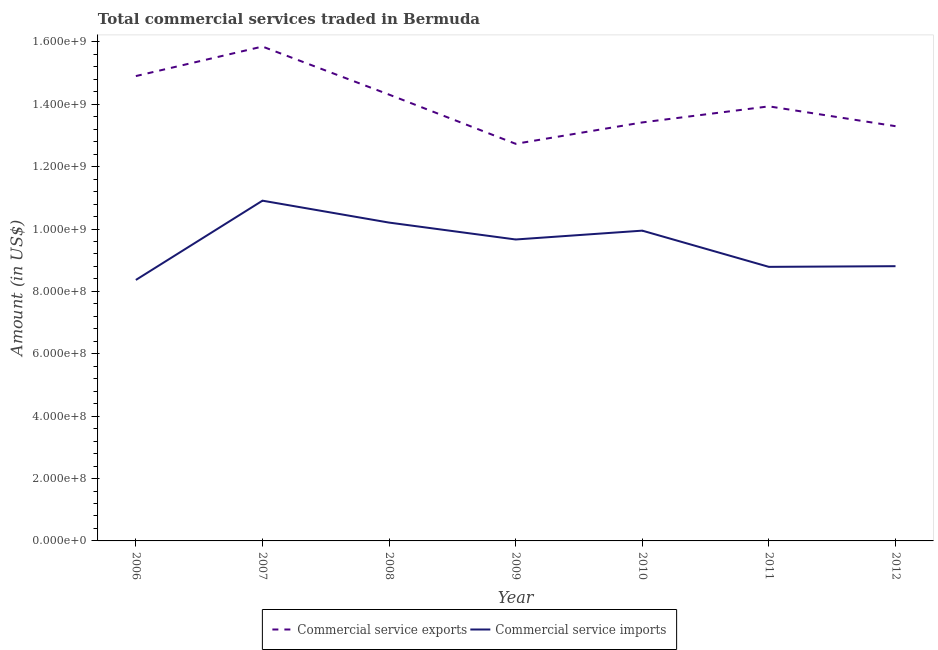How many different coloured lines are there?
Your answer should be compact. 2. Is the number of lines equal to the number of legend labels?
Provide a short and direct response. Yes. What is the amount of commercial service imports in 2007?
Give a very brief answer. 1.09e+09. Across all years, what is the maximum amount of commercial service imports?
Make the answer very short. 1.09e+09. Across all years, what is the minimum amount of commercial service imports?
Ensure brevity in your answer.  8.37e+08. What is the total amount of commercial service exports in the graph?
Offer a terse response. 9.84e+09. What is the difference between the amount of commercial service imports in 2007 and that in 2008?
Your response must be concise. 7.03e+07. What is the difference between the amount of commercial service exports in 2010 and the amount of commercial service imports in 2006?
Offer a terse response. 5.05e+08. What is the average amount of commercial service imports per year?
Provide a short and direct response. 9.53e+08. In the year 2006, what is the difference between the amount of commercial service imports and amount of commercial service exports?
Your answer should be very brief. -6.54e+08. In how many years, is the amount of commercial service exports greater than 1200000000 US$?
Keep it short and to the point. 7. What is the ratio of the amount of commercial service exports in 2006 to that in 2010?
Make the answer very short. 1.11. Is the amount of commercial service imports in 2010 less than that in 2011?
Provide a short and direct response. No. What is the difference between the highest and the second highest amount of commercial service imports?
Provide a short and direct response. 7.03e+07. What is the difference between the highest and the lowest amount of commercial service exports?
Your response must be concise. 3.12e+08. In how many years, is the amount of commercial service imports greater than the average amount of commercial service imports taken over all years?
Offer a terse response. 4. Is the sum of the amount of commercial service exports in 2010 and 2011 greater than the maximum amount of commercial service imports across all years?
Your response must be concise. Yes. Does the amount of commercial service imports monotonically increase over the years?
Your response must be concise. No. How many lines are there?
Give a very brief answer. 2. How many years are there in the graph?
Provide a short and direct response. 7. Does the graph contain any zero values?
Offer a terse response. No. How many legend labels are there?
Your answer should be compact. 2. How are the legend labels stacked?
Provide a short and direct response. Horizontal. What is the title of the graph?
Give a very brief answer. Total commercial services traded in Bermuda. What is the Amount (in US$) of Commercial service exports in 2006?
Your answer should be very brief. 1.49e+09. What is the Amount (in US$) in Commercial service imports in 2006?
Your answer should be compact. 8.37e+08. What is the Amount (in US$) of Commercial service exports in 2007?
Offer a very short reply. 1.58e+09. What is the Amount (in US$) of Commercial service imports in 2007?
Your answer should be compact. 1.09e+09. What is the Amount (in US$) in Commercial service exports in 2008?
Provide a succinct answer. 1.43e+09. What is the Amount (in US$) of Commercial service imports in 2008?
Offer a terse response. 1.02e+09. What is the Amount (in US$) of Commercial service exports in 2009?
Ensure brevity in your answer.  1.27e+09. What is the Amount (in US$) of Commercial service imports in 2009?
Offer a terse response. 9.66e+08. What is the Amount (in US$) in Commercial service exports in 2010?
Your response must be concise. 1.34e+09. What is the Amount (in US$) in Commercial service imports in 2010?
Make the answer very short. 9.95e+08. What is the Amount (in US$) in Commercial service exports in 2011?
Provide a short and direct response. 1.39e+09. What is the Amount (in US$) of Commercial service imports in 2011?
Provide a short and direct response. 8.79e+08. What is the Amount (in US$) in Commercial service exports in 2012?
Keep it short and to the point. 1.33e+09. What is the Amount (in US$) of Commercial service imports in 2012?
Ensure brevity in your answer.  8.81e+08. Across all years, what is the maximum Amount (in US$) in Commercial service exports?
Make the answer very short. 1.58e+09. Across all years, what is the maximum Amount (in US$) of Commercial service imports?
Provide a short and direct response. 1.09e+09. Across all years, what is the minimum Amount (in US$) of Commercial service exports?
Keep it short and to the point. 1.27e+09. Across all years, what is the minimum Amount (in US$) in Commercial service imports?
Make the answer very short. 8.37e+08. What is the total Amount (in US$) of Commercial service exports in the graph?
Ensure brevity in your answer.  9.84e+09. What is the total Amount (in US$) in Commercial service imports in the graph?
Provide a succinct answer. 6.67e+09. What is the difference between the Amount (in US$) in Commercial service exports in 2006 and that in 2007?
Provide a succinct answer. -9.47e+07. What is the difference between the Amount (in US$) in Commercial service imports in 2006 and that in 2007?
Your answer should be compact. -2.54e+08. What is the difference between the Amount (in US$) in Commercial service exports in 2006 and that in 2008?
Keep it short and to the point. 5.94e+07. What is the difference between the Amount (in US$) in Commercial service imports in 2006 and that in 2008?
Your answer should be very brief. -1.84e+08. What is the difference between the Amount (in US$) of Commercial service exports in 2006 and that in 2009?
Provide a short and direct response. 2.17e+08. What is the difference between the Amount (in US$) in Commercial service imports in 2006 and that in 2009?
Your answer should be compact. -1.30e+08. What is the difference between the Amount (in US$) of Commercial service exports in 2006 and that in 2010?
Keep it short and to the point. 1.49e+08. What is the difference between the Amount (in US$) in Commercial service imports in 2006 and that in 2010?
Keep it short and to the point. -1.58e+08. What is the difference between the Amount (in US$) of Commercial service exports in 2006 and that in 2011?
Offer a terse response. 9.71e+07. What is the difference between the Amount (in US$) of Commercial service imports in 2006 and that in 2011?
Your answer should be compact. -4.20e+07. What is the difference between the Amount (in US$) of Commercial service exports in 2006 and that in 2012?
Offer a terse response. 1.61e+08. What is the difference between the Amount (in US$) of Commercial service imports in 2006 and that in 2012?
Ensure brevity in your answer.  -4.41e+07. What is the difference between the Amount (in US$) in Commercial service exports in 2007 and that in 2008?
Your response must be concise. 1.54e+08. What is the difference between the Amount (in US$) in Commercial service imports in 2007 and that in 2008?
Give a very brief answer. 7.03e+07. What is the difference between the Amount (in US$) in Commercial service exports in 2007 and that in 2009?
Your response must be concise. 3.12e+08. What is the difference between the Amount (in US$) of Commercial service imports in 2007 and that in 2009?
Keep it short and to the point. 1.24e+08. What is the difference between the Amount (in US$) of Commercial service exports in 2007 and that in 2010?
Your answer should be very brief. 2.43e+08. What is the difference between the Amount (in US$) of Commercial service imports in 2007 and that in 2010?
Offer a very short reply. 9.61e+07. What is the difference between the Amount (in US$) in Commercial service exports in 2007 and that in 2011?
Your response must be concise. 1.92e+08. What is the difference between the Amount (in US$) in Commercial service imports in 2007 and that in 2011?
Give a very brief answer. 2.12e+08. What is the difference between the Amount (in US$) of Commercial service exports in 2007 and that in 2012?
Make the answer very short. 2.55e+08. What is the difference between the Amount (in US$) of Commercial service imports in 2007 and that in 2012?
Provide a succinct answer. 2.10e+08. What is the difference between the Amount (in US$) of Commercial service exports in 2008 and that in 2009?
Make the answer very short. 1.58e+08. What is the difference between the Amount (in US$) in Commercial service imports in 2008 and that in 2009?
Your answer should be compact. 5.42e+07. What is the difference between the Amount (in US$) in Commercial service exports in 2008 and that in 2010?
Give a very brief answer. 8.92e+07. What is the difference between the Amount (in US$) in Commercial service imports in 2008 and that in 2010?
Provide a succinct answer. 2.58e+07. What is the difference between the Amount (in US$) of Commercial service exports in 2008 and that in 2011?
Make the answer very short. 3.77e+07. What is the difference between the Amount (in US$) in Commercial service imports in 2008 and that in 2011?
Your response must be concise. 1.42e+08. What is the difference between the Amount (in US$) in Commercial service exports in 2008 and that in 2012?
Your response must be concise. 1.01e+08. What is the difference between the Amount (in US$) in Commercial service imports in 2008 and that in 2012?
Keep it short and to the point. 1.40e+08. What is the difference between the Amount (in US$) of Commercial service exports in 2009 and that in 2010?
Offer a very short reply. -6.86e+07. What is the difference between the Amount (in US$) of Commercial service imports in 2009 and that in 2010?
Provide a succinct answer. -2.83e+07. What is the difference between the Amount (in US$) of Commercial service exports in 2009 and that in 2011?
Provide a succinct answer. -1.20e+08. What is the difference between the Amount (in US$) of Commercial service imports in 2009 and that in 2011?
Provide a short and direct response. 8.78e+07. What is the difference between the Amount (in US$) in Commercial service exports in 2009 and that in 2012?
Provide a succinct answer. -5.66e+07. What is the difference between the Amount (in US$) of Commercial service imports in 2009 and that in 2012?
Make the answer very short. 8.56e+07. What is the difference between the Amount (in US$) in Commercial service exports in 2010 and that in 2011?
Offer a terse response. -5.15e+07. What is the difference between the Amount (in US$) in Commercial service imports in 2010 and that in 2011?
Offer a very short reply. 1.16e+08. What is the difference between the Amount (in US$) of Commercial service exports in 2010 and that in 2012?
Give a very brief answer. 1.20e+07. What is the difference between the Amount (in US$) of Commercial service imports in 2010 and that in 2012?
Offer a very short reply. 1.14e+08. What is the difference between the Amount (in US$) in Commercial service exports in 2011 and that in 2012?
Your response must be concise. 6.35e+07. What is the difference between the Amount (in US$) in Commercial service imports in 2011 and that in 2012?
Give a very brief answer. -2.16e+06. What is the difference between the Amount (in US$) of Commercial service exports in 2006 and the Amount (in US$) of Commercial service imports in 2007?
Make the answer very short. 3.99e+08. What is the difference between the Amount (in US$) of Commercial service exports in 2006 and the Amount (in US$) of Commercial service imports in 2008?
Offer a terse response. 4.70e+08. What is the difference between the Amount (in US$) of Commercial service exports in 2006 and the Amount (in US$) of Commercial service imports in 2009?
Provide a short and direct response. 5.24e+08. What is the difference between the Amount (in US$) of Commercial service exports in 2006 and the Amount (in US$) of Commercial service imports in 2010?
Provide a short and direct response. 4.96e+08. What is the difference between the Amount (in US$) in Commercial service exports in 2006 and the Amount (in US$) in Commercial service imports in 2011?
Offer a very short reply. 6.12e+08. What is the difference between the Amount (in US$) in Commercial service exports in 2006 and the Amount (in US$) in Commercial service imports in 2012?
Keep it short and to the point. 6.10e+08. What is the difference between the Amount (in US$) in Commercial service exports in 2007 and the Amount (in US$) in Commercial service imports in 2008?
Ensure brevity in your answer.  5.64e+08. What is the difference between the Amount (in US$) of Commercial service exports in 2007 and the Amount (in US$) of Commercial service imports in 2009?
Provide a short and direct response. 6.19e+08. What is the difference between the Amount (in US$) of Commercial service exports in 2007 and the Amount (in US$) of Commercial service imports in 2010?
Give a very brief answer. 5.90e+08. What is the difference between the Amount (in US$) of Commercial service exports in 2007 and the Amount (in US$) of Commercial service imports in 2011?
Your response must be concise. 7.06e+08. What is the difference between the Amount (in US$) of Commercial service exports in 2007 and the Amount (in US$) of Commercial service imports in 2012?
Offer a very short reply. 7.04e+08. What is the difference between the Amount (in US$) in Commercial service exports in 2008 and the Amount (in US$) in Commercial service imports in 2009?
Make the answer very short. 4.65e+08. What is the difference between the Amount (in US$) of Commercial service exports in 2008 and the Amount (in US$) of Commercial service imports in 2010?
Offer a very short reply. 4.36e+08. What is the difference between the Amount (in US$) in Commercial service exports in 2008 and the Amount (in US$) in Commercial service imports in 2011?
Provide a short and direct response. 5.52e+08. What is the difference between the Amount (in US$) of Commercial service exports in 2008 and the Amount (in US$) of Commercial service imports in 2012?
Offer a terse response. 5.50e+08. What is the difference between the Amount (in US$) of Commercial service exports in 2009 and the Amount (in US$) of Commercial service imports in 2010?
Your answer should be very brief. 2.78e+08. What is the difference between the Amount (in US$) of Commercial service exports in 2009 and the Amount (in US$) of Commercial service imports in 2011?
Your answer should be very brief. 3.94e+08. What is the difference between the Amount (in US$) in Commercial service exports in 2009 and the Amount (in US$) in Commercial service imports in 2012?
Your answer should be compact. 3.92e+08. What is the difference between the Amount (in US$) in Commercial service exports in 2010 and the Amount (in US$) in Commercial service imports in 2011?
Offer a terse response. 4.63e+08. What is the difference between the Amount (in US$) of Commercial service exports in 2010 and the Amount (in US$) of Commercial service imports in 2012?
Give a very brief answer. 4.61e+08. What is the difference between the Amount (in US$) in Commercial service exports in 2011 and the Amount (in US$) in Commercial service imports in 2012?
Offer a terse response. 5.12e+08. What is the average Amount (in US$) of Commercial service exports per year?
Offer a very short reply. 1.41e+09. What is the average Amount (in US$) of Commercial service imports per year?
Provide a short and direct response. 9.53e+08. In the year 2006, what is the difference between the Amount (in US$) of Commercial service exports and Amount (in US$) of Commercial service imports?
Make the answer very short. 6.54e+08. In the year 2007, what is the difference between the Amount (in US$) in Commercial service exports and Amount (in US$) in Commercial service imports?
Keep it short and to the point. 4.94e+08. In the year 2008, what is the difference between the Amount (in US$) of Commercial service exports and Amount (in US$) of Commercial service imports?
Your answer should be compact. 4.10e+08. In the year 2009, what is the difference between the Amount (in US$) of Commercial service exports and Amount (in US$) of Commercial service imports?
Make the answer very short. 3.07e+08. In the year 2010, what is the difference between the Amount (in US$) in Commercial service exports and Amount (in US$) in Commercial service imports?
Offer a terse response. 3.47e+08. In the year 2011, what is the difference between the Amount (in US$) of Commercial service exports and Amount (in US$) of Commercial service imports?
Give a very brief answer. 5.15e+08. In the year 2012, what is the difference between the Amount (in US$) in Commercial service exports and Amount (in US$) in Commercial service imports?
Offer a terse response. 4.49e+08. What is the ratio of the Amount (in US$) in Commercial service exports in 2006 to that in 2007?
Offer a terse response. 0.94. What is the ratio of the Amount (in US$) of Commercial service imports in 2006 to that in 2007?
Offer a very short reply. 0.77. What is the ratio of the Amount (in US$) of Commercial service exports in 2006 to that in 2008?
Offer a very short reply. 1.04. What is the ratio of the Amount (in US$) in Commercial service imports in 2006 to that in 2008?
Make the answer very short. 0.82. What is the ratio of the Amount (in US$) in Commercial service exports in 2006 to that in 2009?
Ensure brevity in your answer.  1.17. What is the ratio of the Amount (in US$) of Commercial service imports in 2006 to that in 2009?
Offer a terse response. 0.87. What is the ratio of the Amount (in US$) in Commercial service exports in 2006 to that in 2010?
Make the answer very short. 1.11. What is the ratio of the Amount (in US$) in Commercial service imports in 2006 to that in 2010?
Make the answer very short. 0.84. What is the ratio of the Amount (in US$) of Commercial service exports in 2006 to that in 2011?
Keep it short and to the point. 1.07. What is the ratio of the Amount (in US$) of Commercial service imports in 2006 to that in 2011?
Your response must be concise. 0.95. What is the ratio of the Amount (in US$) in Commercial service exports in 2006 to that in 2012?
Offer a very short reply. 1.12. What is the ratio of the Amount (in US$) of Commercial service imports in 2006 to that in 2012?
Your answer should be very brief. 0.95. What is the ratio of the Amount (in US$) of Commercial service exports in 2007 to that in 2008?
Your response must be concise. 1.11. What is the ratio of the Amount (in US$) in Commercial service imports in 2007 to that in 2008?
Ensure brevity in your answer.  1.07. What is the ratio of the Amount (in US$) of Commercial service exports in 2007 to that in 2009?
Provide a short and direct response. 1.25. What is the ratio of the Amount (in US$) of Commercial service imports in 2007 to that in 2009?
Offer a terse response. 1.13. What is the ratio of the Amount (in US$) in Commercial service exports in 2007 to that in 2010?
Provide a short and direct response. 1.18. What is the ratio of the Amount (in US$) in Commercial service imports in 2007 to that in 2010?
Your response must be concise. 1.1. What is the ratio of the Amount (in US$) in Commercial service exports in 2007 to that in 2011?
Keep it short and to the point. 1.14. What is the ratio of the Amount (in US$) in Commercial service imports in 2007 to that in 2011?
Ensure brevity in your answer.  1.24. What is the ratio of the Amount (in US$) of Commercial service exports in 2007 to that in 2012?
Offer a very short reply. 1.19. What is the ratio of the Amount (in US$) of Commercial service imports in 2007 to that in 2012?
Make the answer very short. 1.24. What is the ratio of the Amount (in US$) of Commercial service exports in 2008 to that in 2009?
Ensure brevity in your answer.  1.12. What is the ratio of the Amount (in US$) of Commercial service imports in 2008 to that in 2009?
Offer a terse response. 1.06. What is the ratio of the Amount (in US$) of Commercial service exports in 2008 to that in 2010?
Make the answer very short. 1.07. What is the ratio of the Amount (in US$) in Commercial service imports in 2008 to that in 2010?
Keep it short and to the point. 1.03. What is the ratio of the Amount (in US$) of Commercial service exports in 2008 to that in 2011?
Offer a terse response. 1.03. What is the ratio of the Amount (in US$) of Commercial service imports in 2008 to that in 2011?
Your response must be concise. 1.16. What is the ratio of the Amount (in US$) of Commercial service exports in 2008 to that in 2012?
Keep it short and to the point. 1.08. What is the ratio of the Amount (in US$) in Commercial service imports in 2008 to that in 2012?
Ensure brevity in your answer.  1.16. What is the ratio of the Amount (in US$) in Commercial service exports in 2009 to that in 2010?
Your answer should be compact. 0.95. What is the ratio of the Amount (in US$) in Commercial service imports in 2009 to that in 2010?
Offer a very short reply. 0.97. What is the ratio of the Amount (in US$) in Commercial service exports in 2009 to that in 2011?
Keep it short and to the point. 0.91. What is the ratio of the Amount (in US$) in Commercial service imports in 2009 to that in 2011?
Make the answer very short. 1.1. What is the ratio of the Amount (in US$) of Commercial service exports in 2009 to that in 2012?
Ensure brevity in your answer.  0.96. What is the ratio of the Amount (in US$) of Commercial service imports in 2009 to that in 2012?
Provide a short and direct response. 1.1. What is the ratio of the Amount (in US$) of Commercial service exports in 2010 to that in 2011?
Give a very brief answer. 0.96. What is the ratio of the Amount (in US$) of Commercial service imports in 2010 to that in 2011?
Keep it short and to the point. 1.13. What is the ratio of the Amount (in US$) in Commercial service imports in 2010 to that in 2012?
Offer a very short reply. 1.13. What is the ratio of the Amount (in US$) in Commercial service exports in 2011 to that in 2012?
Keep it short and to the point. 1.05. What is the difference between the highest and the second highest Amount (in US$) of Commercial service exports?
Make the answer very short. 9.47e+07. What is the difference between the highest and the second highest Amount (in US$) of Commercial service imports?
Your answer should be very brief. 7.03e+07. What is the difference between the highest and the lowest Amount (in US$) in Commercial service exports?
Make the answer very short. 3.12e+08. What is the difference between the highest and the lowest Amount (in US$) of Commercial service imports?
Your response must be concise. 2.54e+08. 